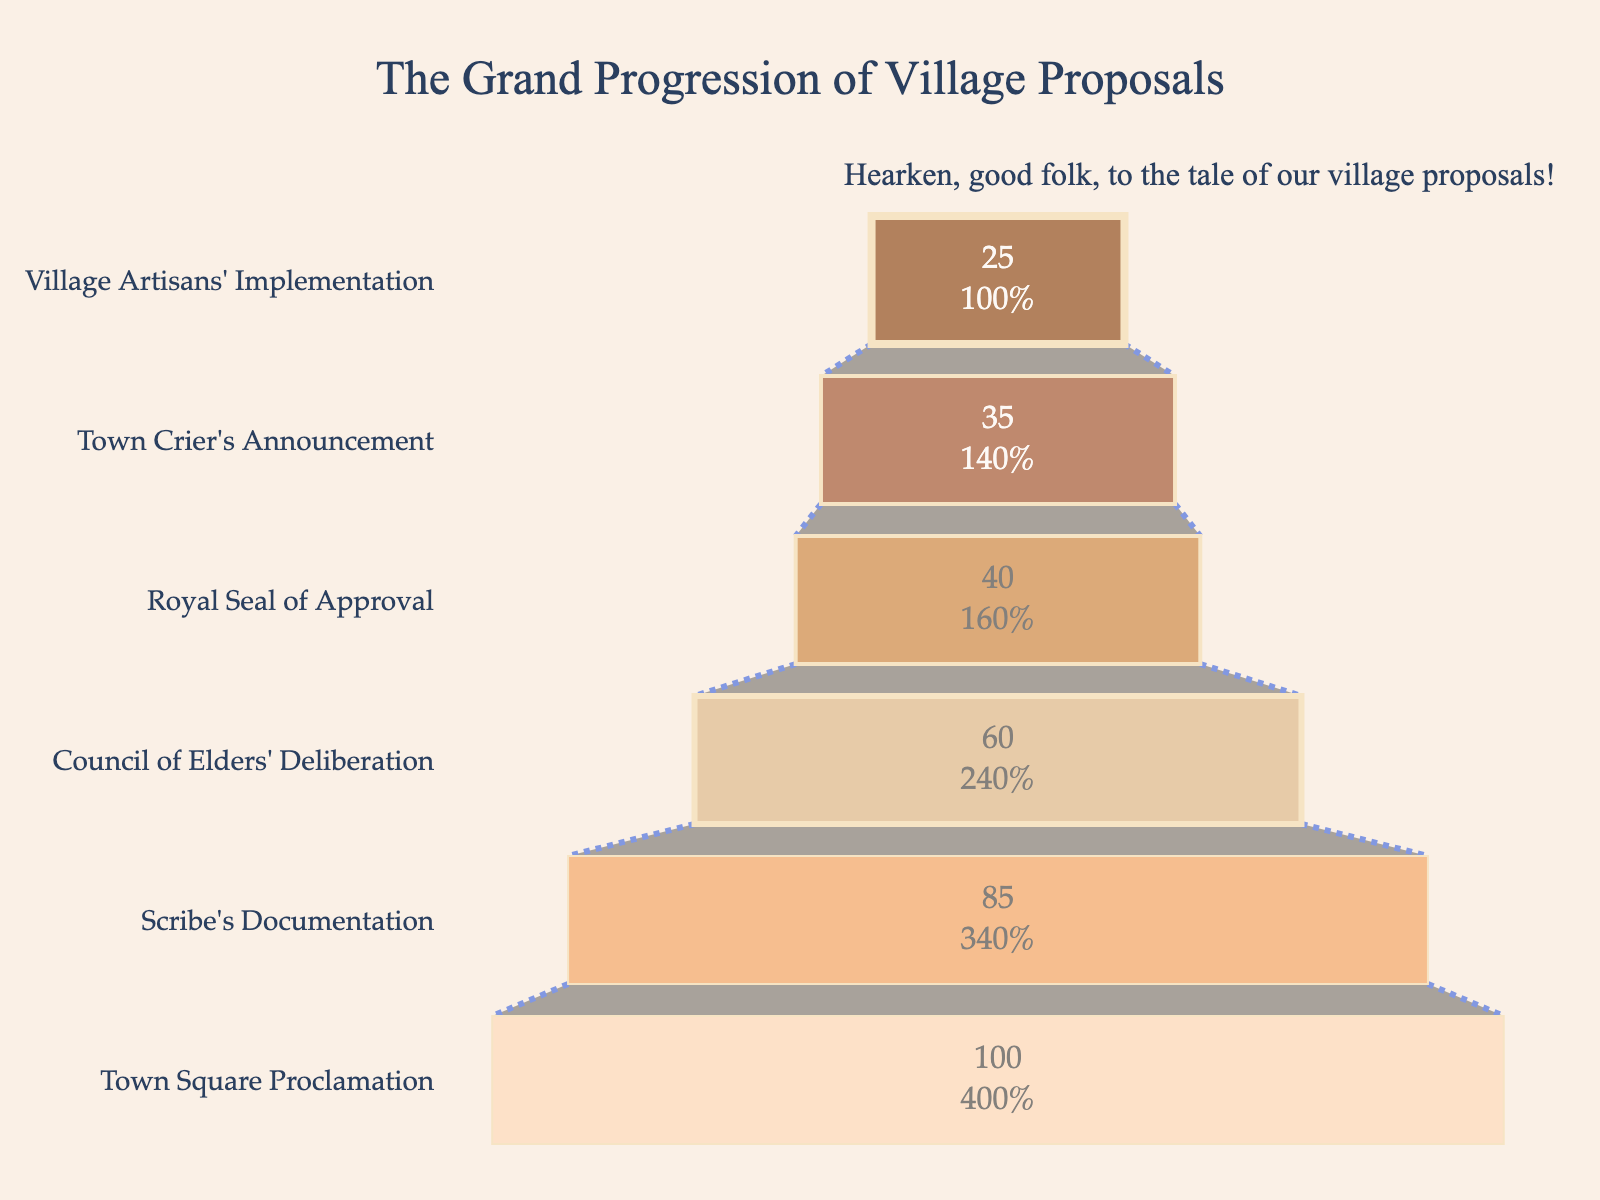What is the title of the funnel chart? The title of a chart is often located at the top of the figure. In this chart, it clearly states the grand theme.
Answer: The Grand Progression of Village Proposals How many stages are illustrated in this funnel chart? Counting the distinct segments from top to bottom reveals the stages. The stages listed are: Town Square Proclamation, Scribe's Documentation, Council of Elders' Deliberation, Royal Seal of Approval, Town Crier's Announcement, Village Artisans' Implementation, totaling six stages.
Answer: 6 Which stage has the highest number of proposals? The top stage in a funnel chart usually represents the highest number. The first stage listed is Town Square Proclamation with 100 proposals.
Answer: Town Square Proclamation What percentage of proposals proceed from Scribe's Documentation to Council of Elders' Deliberation? To find this, divide the number proceeding to Council of Elders' Deliberation (60) by the number in Scribe's Documentation (85) and multiply by 100. (60/85) x 100 ≈ 70.59%.
Answer: 70.59% How many proposals do not receive the Royal Seal of Approval after the Council of Elders' Deliberation? Subtract the number receiving Royal Seal of Approval (40) from the proposals at the Council of Elders' Deliberation stage (60). 60 - 40 = 20.
Answer: 20 What is the decrement in proposals from the Town Crier's Announcement to the Village Artisans' Implementation stage? Subtract the number of proposals at Village Artisans' Implementation (25) from those at Town Crier's Announcement (35). 35 - 25 = 10.
Answer: 10 Between which two stages is the largest drop in the number of proposals observed? By comparing the differences between sequential stages: 
- From Town Square Proclamation to Scribe's Documentation: 100 - 85 = 15
- From Scribe's Documentation to Council of Elders' Deliberation: 85 - 60 = 25
- From Council of Elders' Deliberation to Royal Seal of Approval: 60 - 40 = 20
- From Royal Seal of Approval to Town Crier's Announcement: 40 - 35 = 5
- From Town Crier's Announcement to Village Artisans' Implementation: 35 - 25 = 10. The largest drop is between Scribe's Documentation and Council of Elders' Deliberation.
Answer: Scribe's Documentation and Council of Elders' Deliberation What's the cumulative percentage of proposals remaining from Town Square Proclamation to Town Crier's Announcement? To find this, the cumulative number remaining at Town Crier’s Announcement (35) is divided by the initial number at Town Square Proclamation (100) and multiplied by 100. (35/100) x 100 = 35%.
Answer: 35% What is the visual appearance of the funnel chart representing the proposals? Descriptions of colors and markers help understanding: The stages are represented with varying shades of brown to peach. The width of the lines outlining each stage differs, with the end stages having thinner lines than the beginning ones. The stages are connected with dashed blue lines.
Answer: Varying shades of brown to peach, outlined with varying line widths, connected by dashed blue lines Which two stages are most closely matched in the number of proposals processed? By examining the data for similar values: Scribe's Documentation (85) and Council of Elders' Deliberation (60) are not closely matched compared to Royal Seal of Approval (40) and Town Crier's Announcement (35). The latter two stages have a closer numerical difference (5) than others.
Answer: Royal Seal of Approval and Town Crier's Announcement 